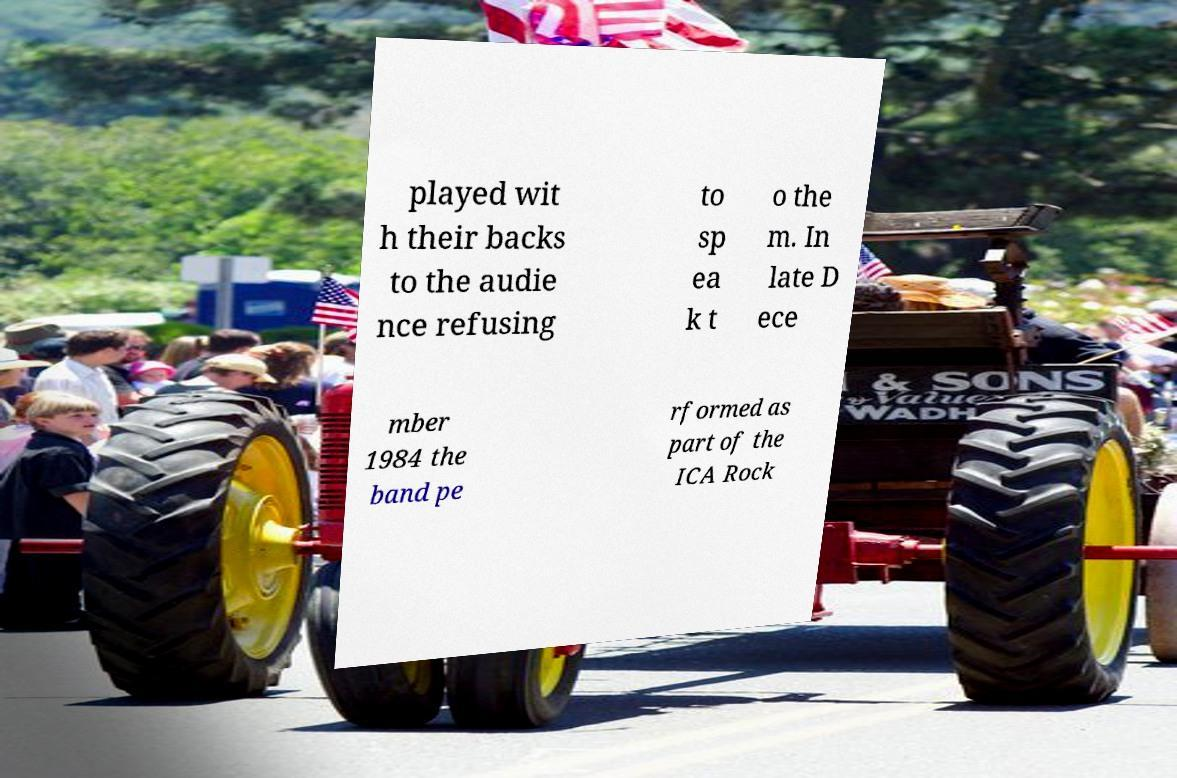Can you read and provide the text displayed in the image?This photo seems to have some interesting text. Can you extract and type it out for me? played wit h their backs to the audie nce refusing to sp ea k t o the m. In late D ece mber 1984 the band pe rformed as part of the ICA Rock 